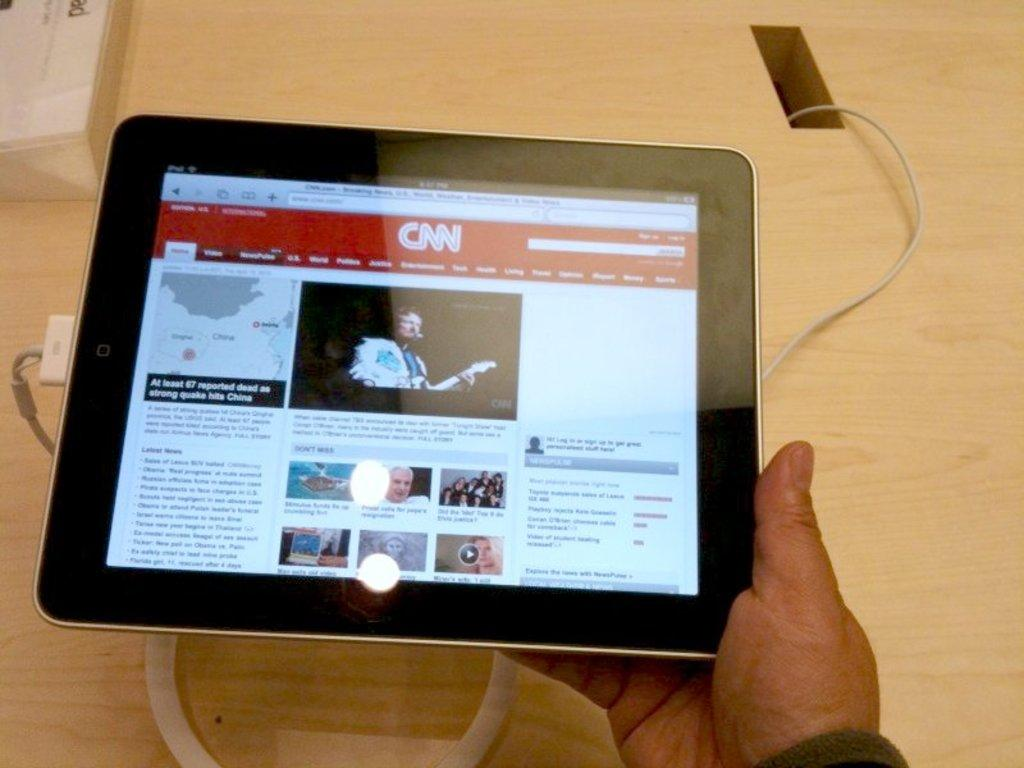What can be seen in the image that belongs to a person? There is a person's hand in the image. What is the person's hand holding? The person's hand is holding a tablet. Where is the tablet placed? The tablet is placed on a table. Is there anything connected to the tablet? Yes, there is a cable connected to the tablet. What type of pie is being served on the table next to the tablet? There is no pie present in the image; it only shows a person's hand holding a tablet placed on a table with a cable connected to it. 